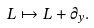<formula> <loc_0><loc_0><loc_500><loc_500>L \mapsto L + \partial _ { y } .</formula> 